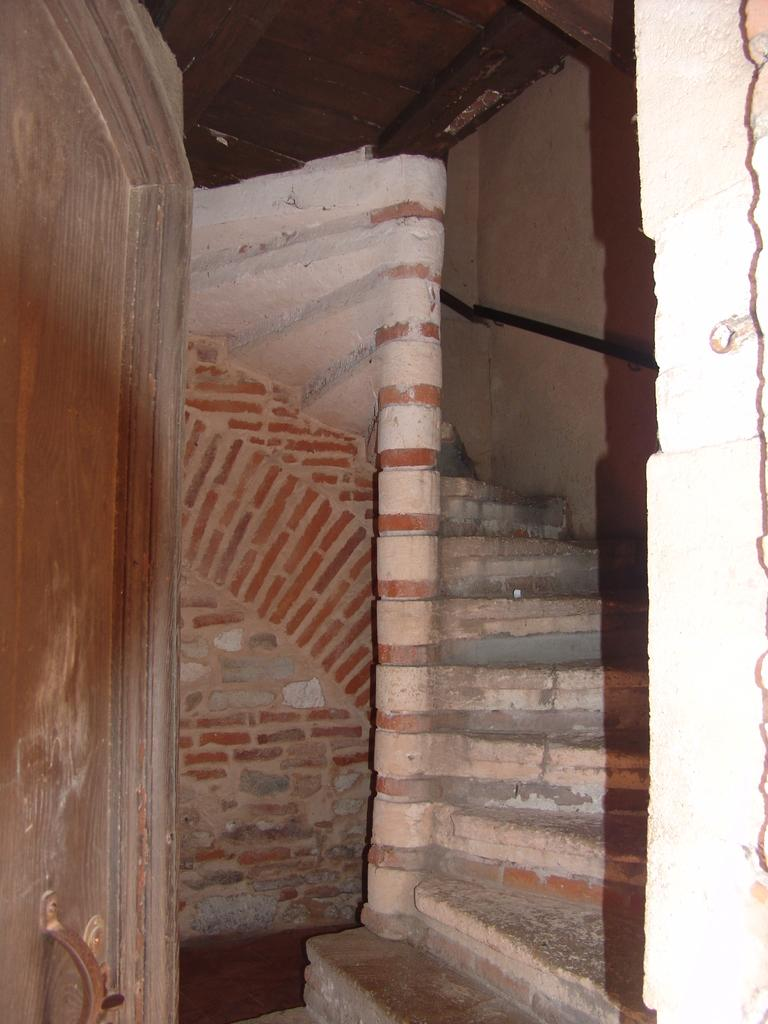What type of structure is visible in the image? There is a brick wall in the image. Can you describe the interior of the house in the image? There are stairs inside the house in the image. What color is the daughter's bath in the image? There is no daughter or bath present in the image. Is there a flame visible on the brick wall in the image? There is no flame visible on the brick wall in the image. 